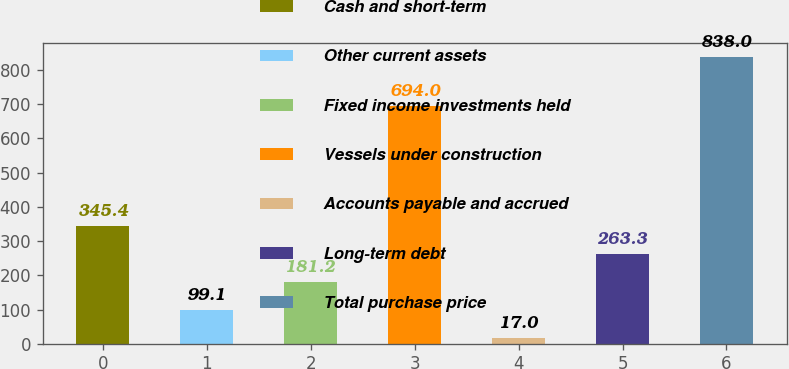Convert chart. <chart><loc_0><loc_0><loc_500><loc_500><bar_chart><fcel>Cash and short-term<fcel>Other current assets<fcel>Fixed income investments held<fcel>Vessels under construction<fcel>Accounts payable and accrued<fcel>Long-term debt<fcel>Total purchase price<nl><fcel>345.4<fcel>99.1<fcel>181.2<fcel>694<fcel>17<fcel>263.3<fcel>838<nl></chart> 